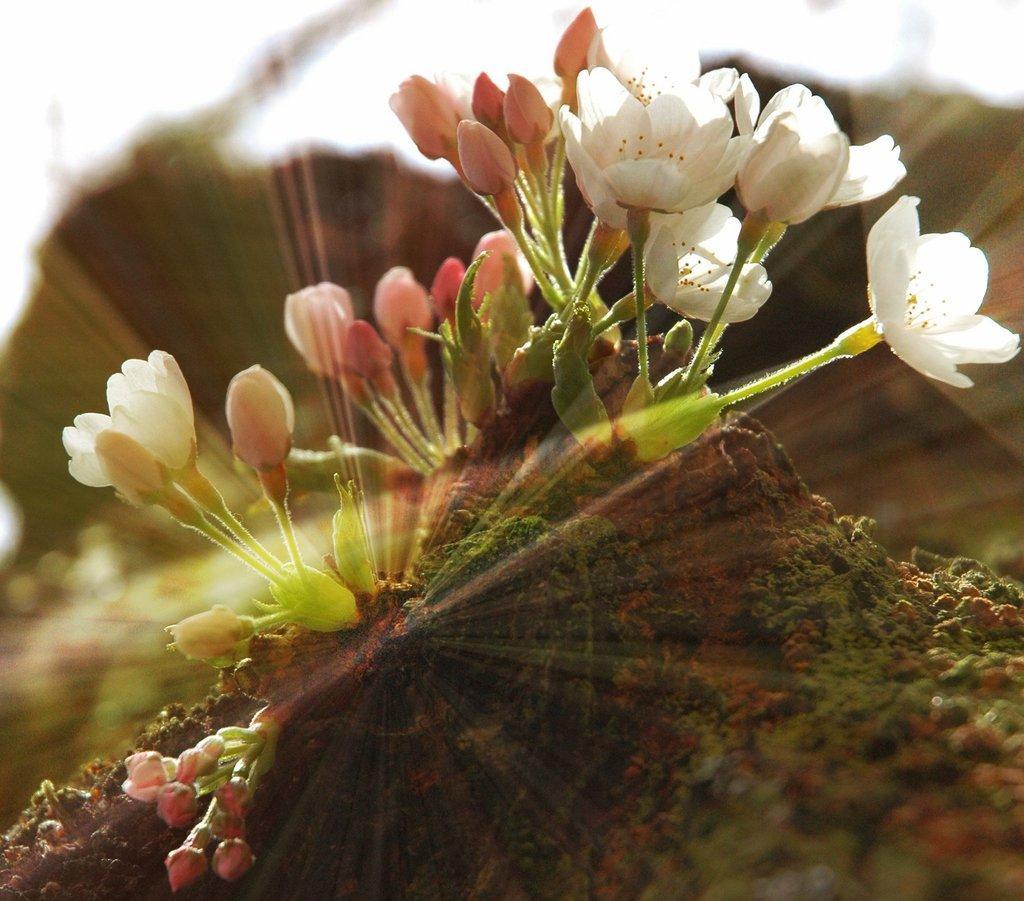In one or two sentences, can you explain what this image depicts? In this picture we can see flowers on the ground and in the background it is blurry. 